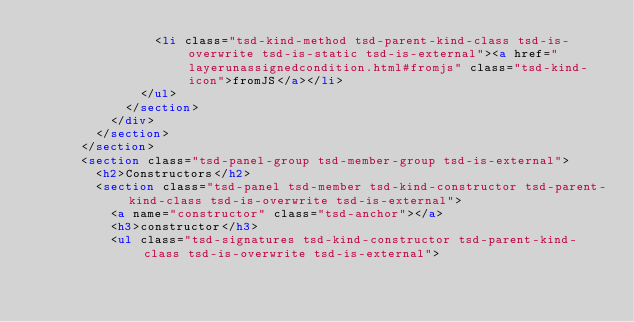<code> <loc_0><loc_0><loc_500><loc_500><_HTML_>								<li class="tsd-kind-method tsd-parent-kind-class tsd-is-overwrite tsd-is-static tsd-is-external"><a href="layerunassignedcondition.html#fromjs" class="tsd-kind-icon">fromJS</a></li>
							</ul>
						</section>
					</div>
				</section>
			</section>
			<section class="tsd-panel-group tsd-member-group tsd-is-external">
				<h2>Constructors</h2>
				<section class="tsd-panel tsd-member tsd-kind-constructor tsd-parent-kind-class tsd-is-overwrite tsd-is-external">
					<a name="constructor" class="tsd-anchor"></a>
					<h3>constructor</h3>
					<ul class="tsd-signatures tsd-kind-constructor tsd-parent-kind-class tsd-is-overwrite tsd-is-external"></code> 